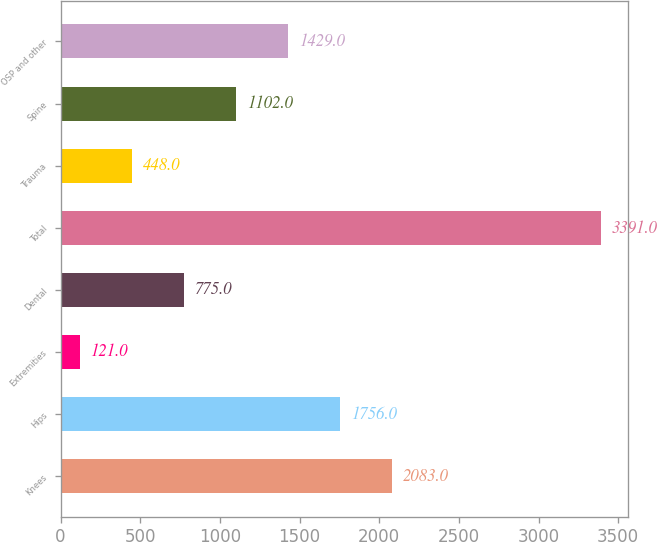Convert chart. <chart><loc_0><loc_0><loc_500><loc_500><bar_chart><fcel>Knees<fcel>Hips<fcel>Extremities<fcel>Dental<fcel>Total<fcel>Trauma<fcel>Spine<fcel>OSP and other<nl><fcel>2083<fcel>1756<fcel>121<fcel>775<fcel>3391<fcel>448<fcel>1102<fcel>1429<nl></chart> 